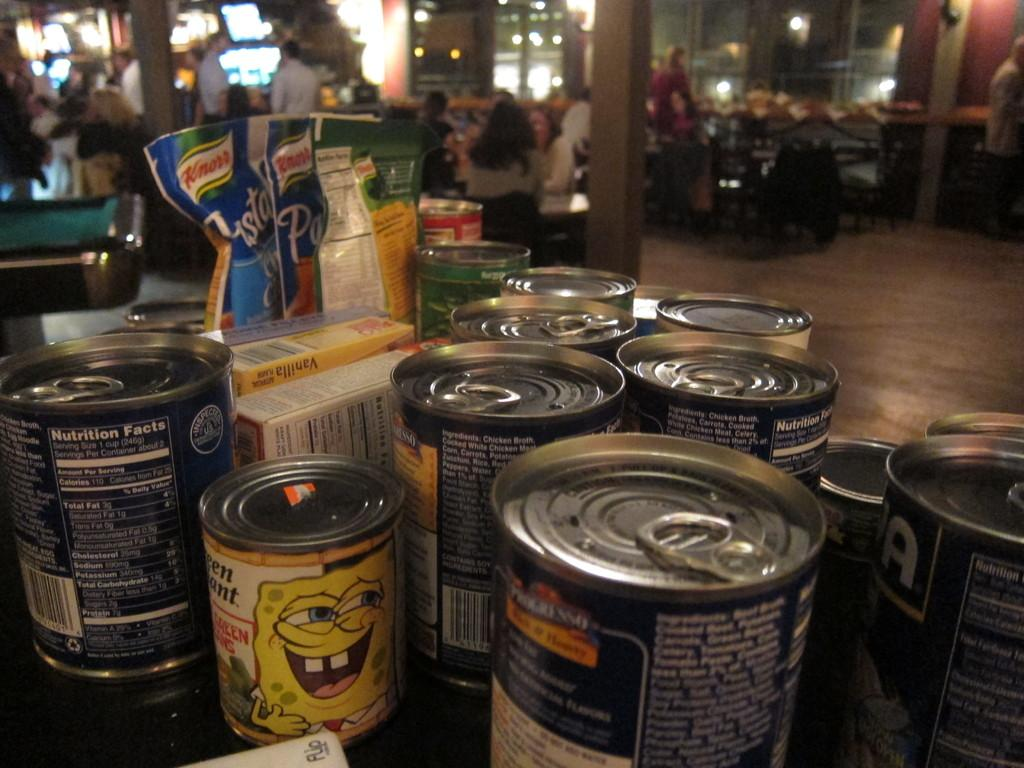What type of objects are present in the image? There are tens in the image. Can you describe the background of the image? The background of the image features pillars, lights, and people sitting on chairs. How is the background of the image depicted? The background appears blurred in the image. What type of cakes are being served to the people sitting on chairs in the image? There are no cakes present in the image; it features tens and a blurred background with pillars, lights, and people sitting on chairs. 